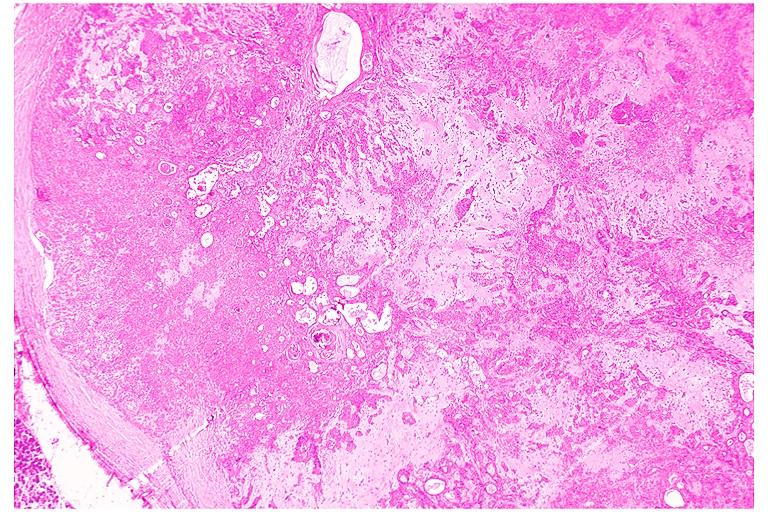s carcinoma present?
Answer the question using a single word or phrase. No 